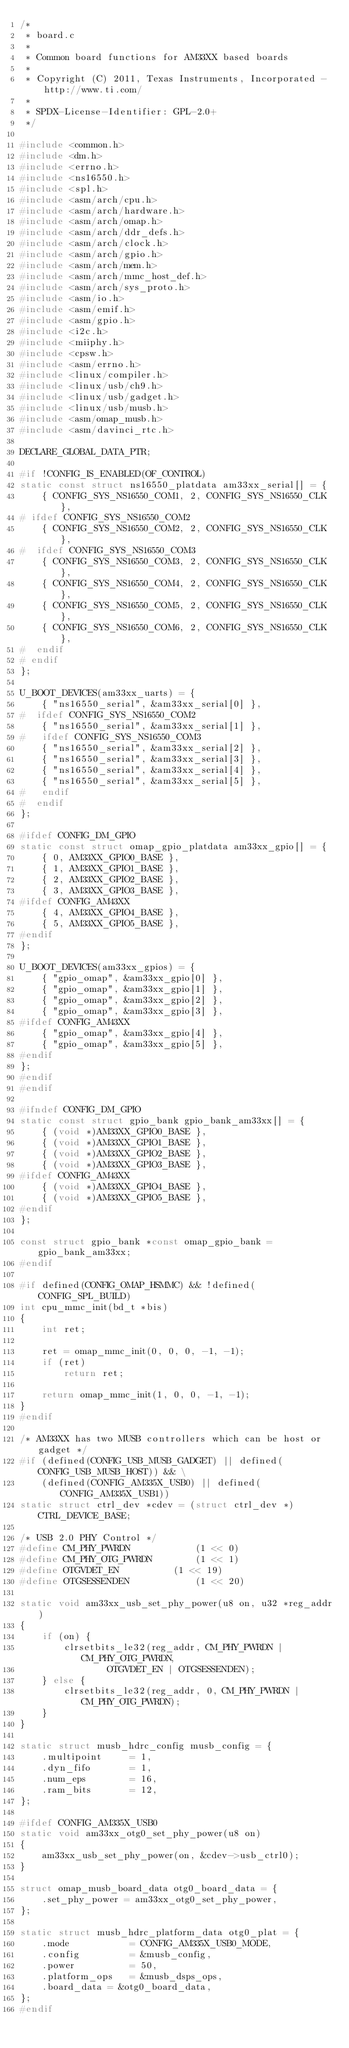<code> <loc_0><loc_0><loc_500><loc_500><_C_>/*
 * board.c
 *
 * Common board functions for AM33XX based boards
 *
 * Copyright (C) 2011, Texas Instruments, Incorporated - http://www.ti.com/
 *
 * SPDX-License-Identifier:	GPL-2.0+
 */

#include <common.h>
#include <dm.h>
#include <errno.h>
#include <ns16550.h>
#include <spl.h>
#include <asm/arch/cpu.h>
#include <asm/arch/hardware.h>
#include <asm/arch/omap.h>
#include <asm/arch/ddr_defs.h>
#include <asm/arch/clock.h>
#include <asm/arch/gpio.h>
#include <asm/arch/mem.h>
#include <asm/arch/mmc_host_def.h>
#include <asm/arch/sys_proto.h>
#include <asm/io.h>
#include <asm/emif.h>
#include <asm/gpio.h>
#include <i2c.h>
#include <miiphy.h>
#include <cpsw.h>
#include <asm/errno.h>
#include <linux/compiler.h>
#include <linux/usb/ch9.h>
#include <linux/usb/gadget.h>
#include <linux/usb/musb.h>
#include <asm/omap_musb.h>
#include <asm/davinci_rtc.h>

DECLARE_GLOBAL_DATA_PTR;

#if !CONFIG_IS_ENABLED(OF_CONTROL)
static const struct ns16550_platdata am33xx_serial[] = {
	{ CONFIG_SYS_NS16550_COM1, 2, CONFIG_SYS_NS16550_CLK },
# ifdef CONFIG_SYS_NS16550_COM2
	{ CONFIG_SYS_NS16550_COM2, 2, CONFIG_SYS_NS16550_CLK },
#  ifdef CONFIG_SYS_NS16550_COM3
	{ CONFIG_SYS_NS16550_COM3, 2, CONFIG_SYS_NS16550_CLK },
	{ CONFIG_SYS_NS16550_COM4, 2, CONFIG_SYS_NS16550_CLK },
	{ CONFIG_SYS_NS16550_COM5, 2, CONFIG_SYS_NS16550_CLK },
	{ CONFIG_SYS_NS16550_COM6, 2, CONFIG_SYS_NS16550_CLK },
#  endif
# endif
};

U_BOOT_DEVICES(am33xx_uarts) = {
	{ "ns16550_serial", &am33xx_serial[0] },
#  ifdef CONFIG_SYS_NS16550_COM2
	{ "ns16550_serial", &am33xx_serial[1] },
#   ifdef CONFIG_SYS_NS16550_COM3
	{ "ns16550_serial", &am33xx_serial[2] },
	{ "ns16550_serial", &am33xx_serial[3] },
	{ "ns16550_serial", &am33xx_serial[4] },
	{ "ns16550_serial", &am33xx_serial[5] },
#   endif
#  endif
};

#ifdef CONFIG_DM_GPIO
static const struct omap_gpio_platdata am33xx_gpio[] = {
	{ 0, AM33XX_GPIO0_BASE },
	{ 1, AM33XX_GPIO1_BASE },
	{ 2, AM33XX_GPIO2_BASE },
	{ 3, AM33XX_GPIO3_BASE },
#ifdef CONFIG_AM43XX
	{ 4, AM33XX_GPIO4_BASE },
	{ 5, AM33XX_GPIO5_BASE },
#endif
};

U_BOOT_DEVICES(am33xx_gpios) = {
	{ "gpio_omap", &am33xx_gpio[0] },
	{ "gpio_omap", &am33xx_gpio[1] },
	{ "gpio_omap", &am33xx_gpio[2] },
	{ "gpio_omap", &am33xx_gpio[3] },
#ifdef CONFIG_AM43XX
	{ "gpio_omap", &am33xx_gpio[4] },
	{ "gpio_omap", &am33xx_gpio[5] },
#endif
};
#endif
#endif

#ifndef CONFIG_DM_GPIO
static const struct gpio_bank gpio_bank_am33xx[] = {
	{ (void *)AM33XX_GPIO0_BASE },
	{ (void *)AM33XX_GPIO1_BASE },
	{ (void *)AM33XX_GPIO2_BASE },
	{ (void *)AM33XX_GPIO3_BASE },
#ifdef CONFIG_AM43XX
	{ (void *)AM33XX_GPIO4_BASE },
	{ (void *)AM33XX_GPIO5_BASE },
#endif
};

const struct gpio_bank *const omap_gpio_bank = gpio_bank_am33xx;
#endif

#if defined(CONFIG_OMAP_HSMMC) && !defined(CONFIG_SPL_BUILD)
int cpu_mmc_init(bd_t *bis)
{
	int ret;

	ret = omap_mmc_init(0, 0, 0, -1, -1);
	if (ret)
		return ret;

	return omap_mmc_init(1, 0, 0, -1, -1);
}
#endif

/* AM33XX has two MUSB controllers which can be host or gadget */
#if (defined(CONFIG_USB_MUSB_GADGET) || defined(CONFIG_USB_MUSB_HOST)) && \
	(defined(CONFIG_AM335X_USB0) || defined(CONFIG_AM335X_USB1))
static struct ctrl_dev *cdev = (struct ctrl_dev *)CTRL_DEVICE_BASE;

/* USB 2.0 PHY Control */
#define CM_PHY_PWRDN			(1 << 0)
#define CM_PHY_OTG_PWRDN		(1 << 1)
#define OTGVDET_EN			(1 << 19)
#define OTGSESSENDEN			(1 << 20)

static void am33xx_usb_set_phy_power(u8 on, u32 *reg_addr)
{
	if (on) {
		clrsetbits_le32(reg_addr, CM_PHY_PWRDN | CM_PHY_OTG_PWRDN,
				OTGVDET_EN | OTGSESSENDEN);
	} else {
		clrsetbits_le32(reg_addr, 0, CM_PHY_PWRDN | CM_PHY_OTG_PWRDN);
	}
}

static struct musb_hdrc_config musb_config = {
	.multipoint     = 1,
	.dyn_fifo       = 1,
	.num_eps        = 16,
	.ram_bits       = 12,
};

#ifdef CONFIG_AM335X_USB0
static void am33xx_otg0_set_phy_power(u8 on)
{
	am33xx_usb_set_phy_power(on, &cdev->usb_ctrl0);
}

struct omap_musb_board_data otg0_board_data = {
	.set_phy_power = am33xx_otg0_set_phy_power,
};

static struct musb_hdrc_platform_data otg0_plat = {
	.mode           = CONFIG_AM335X_USB0_MODE,
	.config         = &musb_config,
	.power          = 50,
	.platform_ops	= &musb_dsps_ops,
	.board_data	= &otg0_board_data,
};
#endif
</code> 